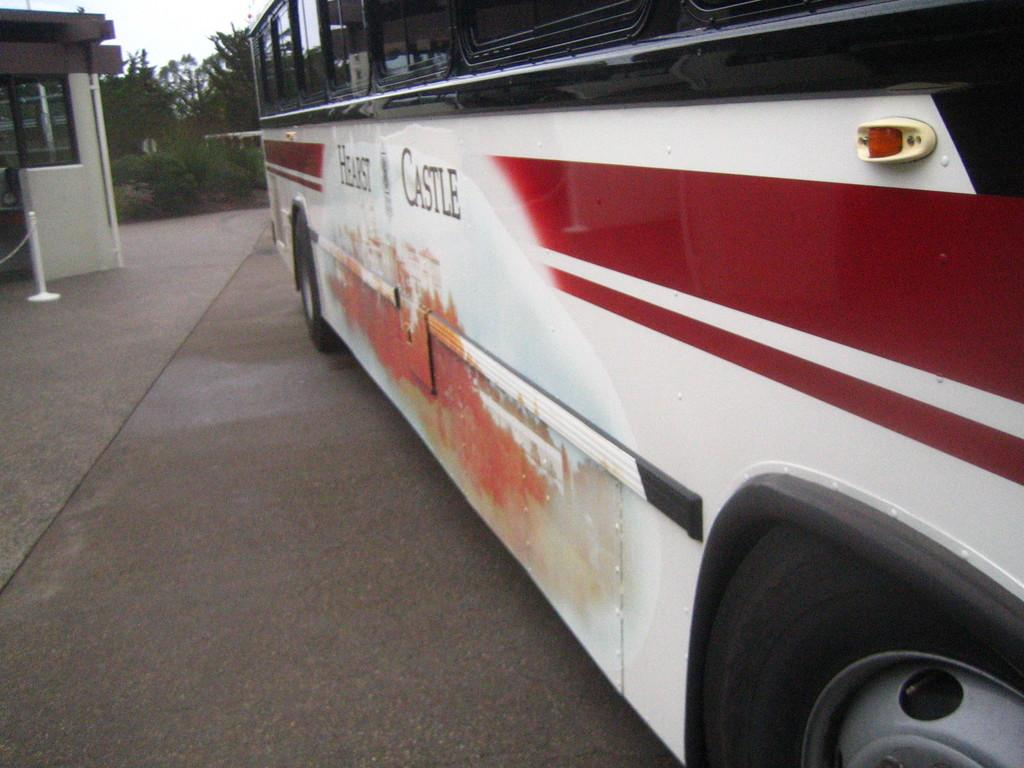What type of vehicle is located on the right side of the image? There is a bus on the right side of the image. What structure is on the left side of the image? There is a house on the left side of the image. What type of vegetation is present in the image? There are trees in the image. What is visible at the top of the image? The sky is visible at the top of the image. How much debt does the bus owe in the image? There is no information about debt in the image, as it features a bus, a house, trees, and the sky. Can you see a monkey climbing one of the trees in the image? There is no monkey present in the image; it only features a bus, a house, trees, and the sky. 